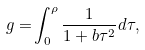Convert formula to latex. <formula><loc_0><loc_0><loc_500><loc_500>g = & \int _ { 0 } ^ { \rho } \frac { 1 } { 1 + b \tau ^ { 2 } } d \tau ,</formula> 